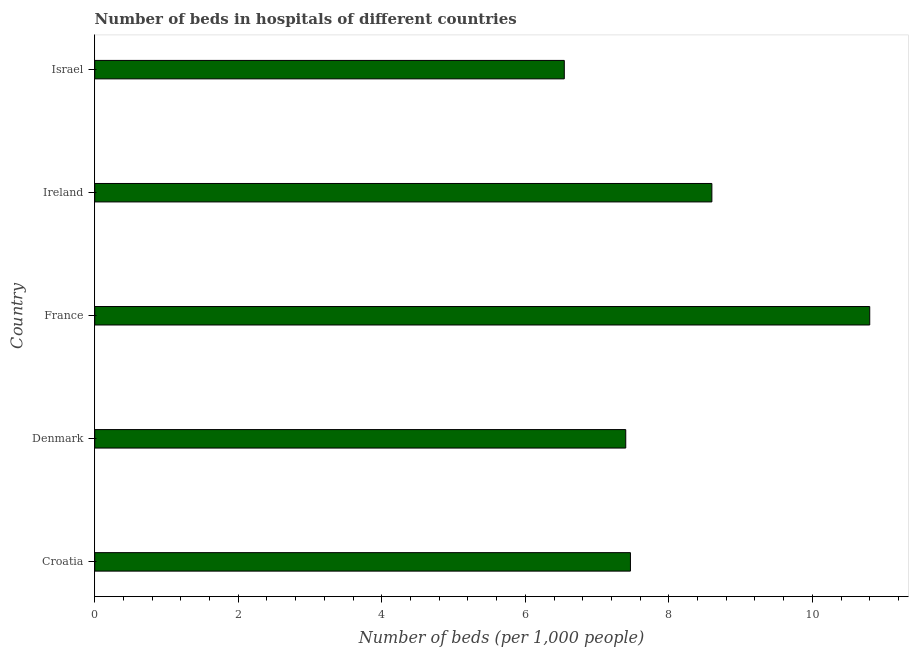Does the graph contain any zero values?
Keep it short and to the point. No. What is the title of the graph?
Give a very brief answer. Number of beds in hospitals of different countries. What is the label or title of the X-axis?
Provide a short and direct response. Number of beds (per 1,0 people). What is the label or title of the Y-axis?
Make the answer very short. Country. What is the number of hospital beds in Israel?
Offer a terse response. 6.54. Across all countries, what is the maximum number of hospital beds?
Your answer should be very brief. 10.8. Across all countries, what is the minimum number of hospital beds?
Give a very brief answer. 6.54. In which country was the number of hospital beds maximum?
Your answer should be compact. France. What is the sum of the number of hospital beds?
Offer a very short reply. 40.81. What is the difference between the number of hospital beds in France and Ireland?
Your response must be concise. 2.2. What is the average number of hospital beds per country?
Keep it short and to the point. 8.16. What is the median number of hospital beds?
Keep it short and to the point. 7.47. In how many countries, is the number of hospital beds greater than 5.2 %?
Make the answer very short. 5. What is the ratio of the number of hospital beds in Denmark to that in France?
Your answer should be very brief. 0.69. What is the difference between the highest and the second highest number of hospital beds?
Ensure brevity in your answer.  2.2. What is the difference between the highest and the lowest number of hospital beds?
Your response must be concise. 4.26. In how many countries, is the number of hospital beds greater than the average number of hospital beds taken over all countries?
Offer a terse response. 2. How many bars are there?
Your answer should be very brief. 5. Are all the bars in the graph horizontal?
Keep it short and to the point. Yes. How many countries are there in the graph?
Provide a short and direct response. 5. What is the difference between two consecutive major ticks on the X-axis?
Your answer should be compact. 2. What is the Number of beds (per 1,000 people) in Croatia?
Provide a short and direct response. 7.47. What is the Number of beds (per 1,000 people) in Denmark?
Your answer should be compact. 7.4. What is the Number of beds (per 1,000 people) in France?
Offer a very short reply. 10.8. What is the Number of beds (per 1,000 people) of Ireland?
Keep it short and to the point. 8.6. What is the Number of beds (per 1,000 people) of Israel?
Offer a terse response. 6.54. What is the difference between the Number of beds (per 1,000 people) in Croatia and Denmark?
Give a very brief answer. 0.07. What is the difference between the Number of beds (per 1,000 people) in Croatia and France?
Your response must be concise. -3.33. What is the difference between the Number of beds (per 1,000 people) in Croatia and Ireland?
Your response must be concise. -1.13. What is the difference between the Number of beds (per 1,000 people) in Croatia and Israel?
Ensure brevity in your answer.  0.92. What is the difference between the Number of beds (per 1,000 people) in Denmark and Ireland?
Your answer should be very brief. -1.2. What is the difference between the Number of beds (per 1,000 people) in Denmark and Israel?
Provide a short and direct response. 0.86. What is the difference between the Number of beds (per 1,000 people) in France and Ireland?
Provide a succinct answer. 2.2. What is the difference between the Number of beds (per 1,000 people) in France and Israel?
Give a very brief answer. 4.26. What is the difference between the Number of beds (per 1,000 people) in Ireland and Israel?
Provide a short and direct response. 2.06. What is the ratio of the Number of beds (per 1,000 people) in Croatia to that in France?
Your answer should be compact. 0.69. What is the ratio of the Number of beds (per 1,000 people) in Croatia to that in Ireland?
Your answer should be compact. 0.87. What is the ratio of the Number of beds (per 1,000 people) in Croatia to that in Israel?
Offer a very short reply. 1.14. What is the ratio of the Number of beds (per 1,000 people) in Denmark to that in France?
Offer a terse response. 0.69. What is the ratio of the Number of beds (per 1,000 people) in Denmark to that in Ireland?
Your answer should be compact. 0.86. What is the ratio of the Number of beds (per 1,000 people) in Denmark to that in Israel?
Keep it short and to the point. 1.13. What is the ratio of the Number of beds (per 1,000 people) in France to that in Ireland?
Ensure brevity in your answer.  1.26. What is the ratio of the Number of beds (per 1,000 people) in France to that in Israel?
Give a very brief answer. 1.65. What is the ratio of the Number of beds (per 1,000 people) in Ireland to that in Israel?
Your response must be concise. 1.31. 